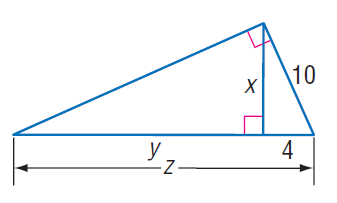Answer the mathemtical geometry problem and directly provide the correct option letter.
Question: Find z.
Choices: A: 17 B: 20 C: 21 D: 25 D 